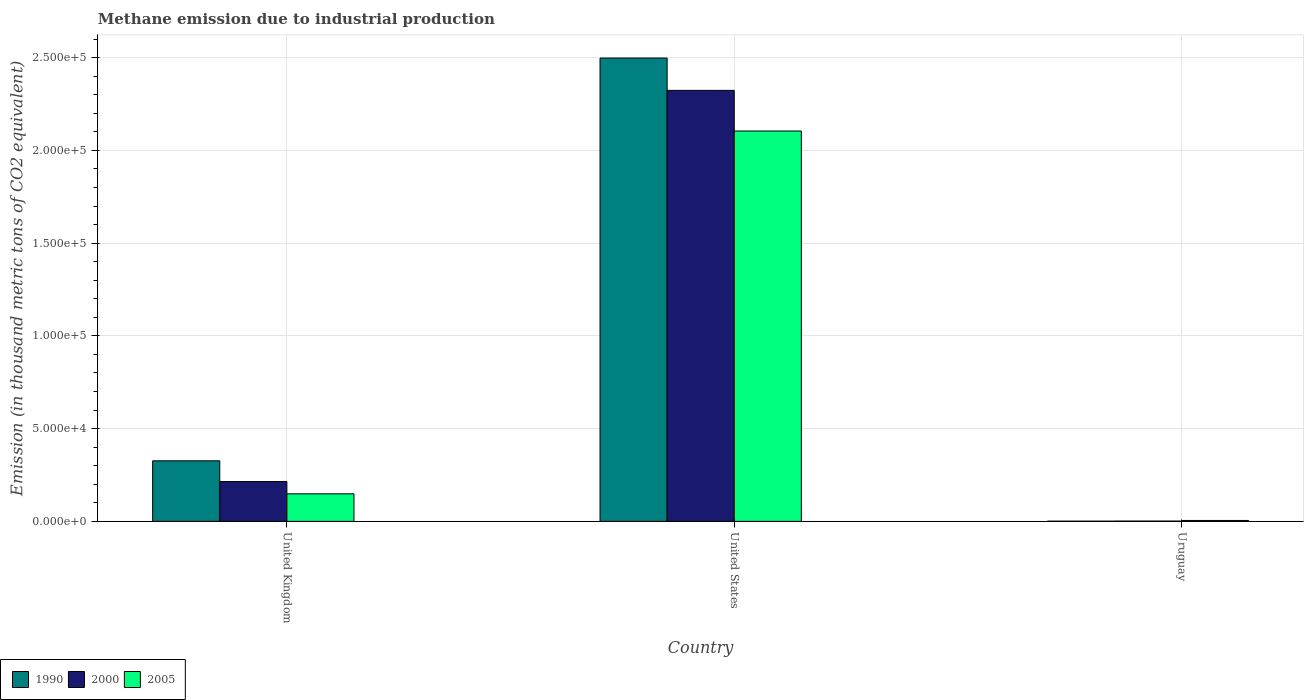Are the number of bars on each tick of the X-axis equal?
Your response must be concise. Yes. How many bars are there on the 3rd tick from the left?
Your response must be concise. 3. How many bars are there on the 2nd tick from the right?
Provide a succinct answer. 3. What is the label of the 2nd group of bars from the left?
Ensure brevity in your answer.  United States. What is the amount of methane emitted in 2005 in Uruguay?
Your response must be concise. 485.4. Across all countries, what is the maximum amount of methane emitted in 1990?
Keep it short and to the point. 2.50e+05. Across all countries, what is the minimum amount of methane emitted in 2005?
Offer a very short reply. 485.4. In which country was the amount of methane emitted in 1990 maximum?
Your answer should be compact. United States. In which country was the amount of methane emitted in 2005 minimum?
Give a very brief answer. Uruguay. What is the total amount of methane emitted in 1990 in the graph?
Ensure brevity in your answer.  2.83e+05. What is the difference between the amount of methane emitted in 2000 in United Kingdom and that in Uruguay?
Your answer should be compact. 2.13e+04. What is the difference between the amount of methane emitted in 2005 in United Kingdom and the amount of methane emitted in 1990 in United States?
Your answer should be compact. -2.35e+05. What is the average amount of methane emitted in 2000 per country?
Provide a succinct answer. 8.47e+04. What is the difference between the amount of methane emitted of/in 1990 and amount of methane emitted of/in 2005 in Uruguay?
Give a very brief answer. -375.1. What is the ratio of the amount of methane emitted in 2000 in United States to that in Uruguay?
Keep it short and to the point. 1505.06. Is the amount of methane emitted in 2005 in United Kingdom less than that in Uruguay?
Your answer should be compact. No. Is the difference between the amount of methane emitted in 1990 in United States and Uruguay greater than the difference between the amount of methane emitted in 2005 in United States and Uruguay?
Keep it short and to the point. Yes. What is the difference between the highest and the second highest amount of methane emitted in 1990?
Provide a short and direct response. -2.50e+05. What is the difference between the highest and the lowest amount of methane emitted in 2000?
Offer a terse response. 2.32e+05. Is the sum of the amount of methane emitted in 2000 in United Kingdom and United States greater than the maximum amount of methane emitted in 1990 across all countries?
Keep it short and to the point. Yes. Is it the case that in every country, the sum of the amount of methane emitted in 2005 and amount of methane emitted in 1990 is greater than the amount of methane emitted in 2000?
Make the answer very short. Yes. How many countries are there in the graph?
Your answer should be very brief. 3. What is the difference between two consecutive major ticks on the Y-axis?
Offer a terse response. 5.00e+04. Does the graph contain any zero values?
Offer a terse response. No. How many legend labels are there?
Ensure brevity in your answer.  3. What is the title of the graph?
Make the answer very short. Methane emission due to industrial production. Does "1984" appear as one of the legend labels in the graph?
Ensure brevity in your answer.  No. What is the label or title of the Y-axis?
Your answer should be very brief. Emission (in thousand metric tons of CO2 equivalent). What is the Emission (in thousand metric tons of CO2 equivalent) in 1990 in United Kingdom?
Give a very brief answer. 3.27e+04. What is the Emission (in thousand metric tons of CO2 equivalent) in 2000 in United Kingdom?
Offer a terse response. 2.15e+04. What is the Emission (in thousand metric tons of CO2 equivalent) in 2005 in United Kingdom?
Provide a succinct answer. 1.48e+04. What is the Emission (in thousand metric tons of CO2 equivalent) of 1990 in United States?
Ensure brevity in your answer.  2.50e+05. What is the Emission (in thousand metric tons of CO2 equivalent) in 2000 in United States?
Your answer should be compact. 2.32e+05. What is the Emission (in thousand metric tons of CO2 equivalent) of 2005 in United States?
Ensure brevity in your answer.  2.10e+05. What is the Emission (in thousand metric tons of CO2 equivalent) of 1990 in Uruguay?
Provide a short and direct response. 110.3. What is the Emission (in thousand metric tons of CO2 equivalent) of 2000 in Uruguay?
Offer a very short reply. 154.4. What is the Emission (in thousand metric tons of CO2 equivalent) of 2005 in Uruguay?
Your answer should be compact. 485.4. Across all countries, what is the maximum Emission (in thousand metric tons of CO2 equivalent) of 1990?
Your answer should be very brief. 2.50e+05. Across all countries, what is the maximum Emission (in thousand metric tons of CO2 equivalent) of 2000?
Provide a succinct answer. 2.32e+05. Across all countries, what is the maximum Emission (in thousand metric tons of CO2 equivalent) in 2005?
Provide a short and direct response. 2.10e+05. Across all countries, what is the minimum Emission (in thousand metric tons of CO2 equivalent) of 1990?
Provide a succinct answer. 110.3. Across all countries, what is the minimum Emission (in thousand metric tons of CO2 equivalent) in 2000?
Offer a terse response. 154.4. Across all countries, what is the minimum Emission (in thousand metric tons of CO2 equivalent) in 2005?
Provide a succinct answer. 485.4. What is the total Emission (in thousand metric tons of CO2 equivalent) in 1990 in the graph?
Offer a very short reply. 2.83e+05. What is the total Emission (in thousand metric tons of CO2 equivalent) in 2000 in the graph?
Keep it short and to the point. 2.54e+05. What is the total Emission (in thousand metric tons of CO2 equivalent) in 2005 in the graph?
Keep it short and to the point. 2.26e+05. What is the difference between the Emission (in thousand metric tons of CO2 equivalent) of 1990 in United Kingdom and that in United States?
Your response must be concise. -2.17e+05. What is the difference between the Emission (in thousand metric tons of CO2 equivalent) of 2000 in United Kingdom and that in United States?
Give a very brief answer. -2.11e+05. What is the difference between the Emission (in thousand metric tons of CO2 equivalent) of 2005 in United Kingdom and that in United States?
Your answer should be compact. -1.96e+05. What is the difference between the Emission (in thousand metric tons of CO2 equivalent) of 1990 in United Kingdom and that in Uruguay?
Provide a short and direct response. 3.25e+04. What is the difference between the Emission (in thousand metric tons of CO2 equivalent) of 2000 in United Kingdom and that in Uruguay?
Offer a very short reply. 2.13e+04. What is the difference between the Emission (in thousand metric tons of CO2 equivalent) in 2005 in United Kingdom and that in Uruguay?
Ensure brevity in your answer.  1.44e+04. What is the difference between the Emission (in thousand metric tons of CO2 equivalent) in 1990 in United States and that in Uruguay?
Give a very brief answer. 2.50e+05. What is the difference between the Emission (in thousand metric tons of CO2 equivalent) of 2000 in United States and that in Uruguay?
Your response must be concise. 2.32e+05. What is the difference between the Emission (in thousand metric tons of CO2 equivalent) in 2005 in United States and that in Uruguay?
Give a very brief answer. 2.10e+05. What is the difference between the Emission (in thousand metric tons of CO2 equivalent) in 1990 in United Kingdom and the Emission (in thousand metric tons of CO2 equivalent) in 2000 in United States?
Your response must be concise. -2.00e+05. What is the difference between the Emission (in thousand metric tons of CO2 equivalent) of 1990 in United Kingdom and the Emission (in thousand metric tons of CO2 equivalent) of 2005 in United States?
Provide a short and direct response. -1.78e+05. What is the difference between the Emission (in thousand metric tons of CO2 equivalent) in 2000 in United Kingdom and the Emission (in thousand metric tons of CO2 equivalent) in 2005 in United States?
Keep it short and to the point. -1.89e+05. What is the difference between the Emission (in thousand metric tons of CO2 equivalent) of 1990 in United Kingdom and the Emission (in thousand metric tons of CO2 equivalent) of 2000 in Uruguay?
Keep it short and to the point. 3.25e+04. What is the difference between the Emission (in thousand metric tons of CO2 equivalent) of 1990 in United Kingdom and the Emission (in thousand metric tons of CO2 equivalent) of 2005 in Uruguay?
Provide a short and direct response. 3.22e+04. What is the difference between the Emission (in thousand metric tons of CO2 equivalent) in 2000 in United Kingdom and the Emission (in thousand metric tons of CO2 equivalent) in 2005 in Uruguay?
Your response must be concise. 2.10e+04. What is the difference between the Emission (in thousand metric tons of CO2 equivalent) in 1990 in United States and the Emission (in thousand metric tons of CO2 equivalent) in 2000 in Uruguay?
Your response must be concise. 2.50e+05. What is the difference between the Emission (in thousand metric tons of CO2 equivalent) in 1990 in United States and the Emission (in thousand metric tons of CO2 equivalent) in 2005 in Uruguay?
Your response must be concise. 2.49e+05. What is the difference between the Emission (in thousand metric tons of CO2 equivalent) of 2000 in United States and the Emission (in thousand metric tons of CO2 equivalent) of 2005 in Uruguay?
Offer a very short reply. 2.32e+05. What is the average Emission (in thousand metric tons of CO2 equivalent) in 1990 per country?
Your response must be concise. 9.42e+04. What is the average Emission (in thousand metric tons of CO2 equivalent) of 2000 per country?
Provide a succinct answer. 8.47e+04. What is the average Emission (in thousand metric tons of CO2 equivalent) of 2005 per country?
Make the answer very short. 7.53e+04. What is the difference between the Emission (in thousand metric tons of CO2 equivalent) of 1990 and Emission (in thousand metric tons of CO2 equivalent) of 2000 in United Kingdom?
Give a very brief answer. 1.12e+04. What is the difference between the Emission (in thousand metric tons of CO2 equivalent) of 1990 and Emission (in thousand metric tons of CO2 equivalent) of 2005 in United Kingdom?
Ensure brevity in your answer.  1.78e+04. What is the difference between the Emission (in thousand metric tons of CO2 equivalent) in 2000 and Emission (in thousand metric tons of CO2 equivalent) in 2005 in United Kingdom?
Offer a very short reply. 6631. What is the difference between the Emission (in thousand metric tons of CO2 equivalent) in 1990 and Emission (in thousand metric tons of CO2 equivalent) in 2000 in United States?
Offer a very short reply. 1.74e+04. What is the difference between the Emission (in thousand metric tons of CO2 equivalent) of 1990 and Emission (in thousand metric tons of CO2 equivalent) of 2005 in United States?
Give a very brief answer. 3.93e+04. What is the difference between the Emission (in thousand metric tons of CO2 equivalent) of 2000 and Emission (in thousand metric tons of CO2 equivalent) of 2005 in United States?
Provide a succinct answer. 2.19e+04. What is the difference between the Emission (in thousand metric tons of CO2 equivalent) of 1990 and Emission (in thousand metric tons of CO2 equivalent) of 2000 in Uruguay?
Your answer should be very brief. -44.1. What is the difference between the Emission (in thousand metric tons of CO2 equivalent) of 1990 and Emission (in thousand metric tons of CO2 equivalent) of 2005 in Uruguay?
Keep it short and to the point. -375.1. What is the difference between the Emission (in thousand metric tons of CO2 equivalent) of 2000 and Emission (in thousand metric tons of CO2 equivalent) of 2005 in Uruguay?
Provide a succinct answer. -331. What is the ratio of the Emission (in thousand metric tons of CO2 equivalent) of 1990 in United Kingdom to that in United States?
Offer a terse response. 0.13. What is the ratio of the Emission (in thousand metric tons of CO2 equivalent) in 2000 in United Kingdom to that in United States?
Offer a terse response. 0.09. What is the ratio of the Emission (in thousand metric tons of CO2 equivalent) in 2005 in United Kingdom to that in United States?
Your response must be concise. 0.07. What is the ratio of the Emission (in thousand metric tons of CO2 equivalent) of 1990 in United Kingdom to that in Uruguay?
Your response must be concise. 296.05. What is the ratio of the Emission (in thousand metric tons of CO2 equivalent) in 2000 in United Kingdom to that in Uruguay?
Make the answer very short. 139.06. What is the ratio of the Emission (in thousand metric tons of CO2 equivalent) in 2005 in United Kingdom to that in Uruguay?
Ensure brevity in your answer.  30.57. What is the ratio of the Emission (in thousand metric tons of CO2 equivalent) of 1990 in United States to that in Uruguay?
Your response must be concise. 2264.86. What is the ratio of the Emission (in thousand metric tons of CO2 equivalent) of 2000 in United States to that in Uruguay?
Your response must be concise. 1505.06. What is the ratio of the Emission (in thousand metric tons of CO2 equivalent) of 2005 in United States to that in Uruguay?
Provide a succinct answer. 433.6. What is the difference between the highest and the second highest Emission (in thousand metric tons of CO2 equivalent) of 1990?
Your answer should be compact. 2.17e+05. What is the difference between the highest and the second highest Emission (in thousand metric tons of CO2 equivalent) in 2000?
Provide a succinct answer. 2.11e+05. What is the difference between the highest and the second highest Emission (in thousand metric tons of CO2 equivalent) of 2005?
Keep it short and to the point. 1.96e+05. What is the difference between the highest and the lowest Emission (in thousand metric tons of CO2 equivalent) of 1990?
Ensure brevity in your answer.  2.50e+05. What is the difference between the highest and the lowest Emission (in thousand metric tons of CO2 equivalent) in 2000?
Your answer should be compact. 2.32e+05. What is the difference between the highest and the lowest Emission (in thousand metric tons of CO2 equivalent) of 2005?
Your answer should be compact. 2.10e+05. 